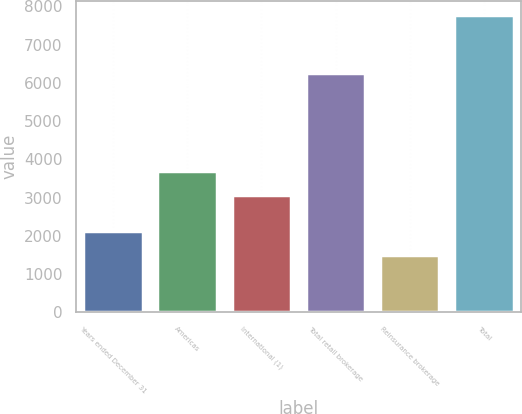Convert chart to OTSL. <chart><loc_0><loc_0><loc_500><loc_500><bar_chart><fcel>Years ended December 31<fcel>Americas<fcel>International (1)<fcel>Total retail brokerage<fcel>Reinsurance brokerage<fcel>Total<nl><fcel>2130.6<fcel>3690.6<fcel>3065<fcel>6256<fcel>1505<fcel>7761<nl></chart> 